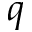<formula> <loc_0><loc_0><loc_500><loc_500>q</formula> 